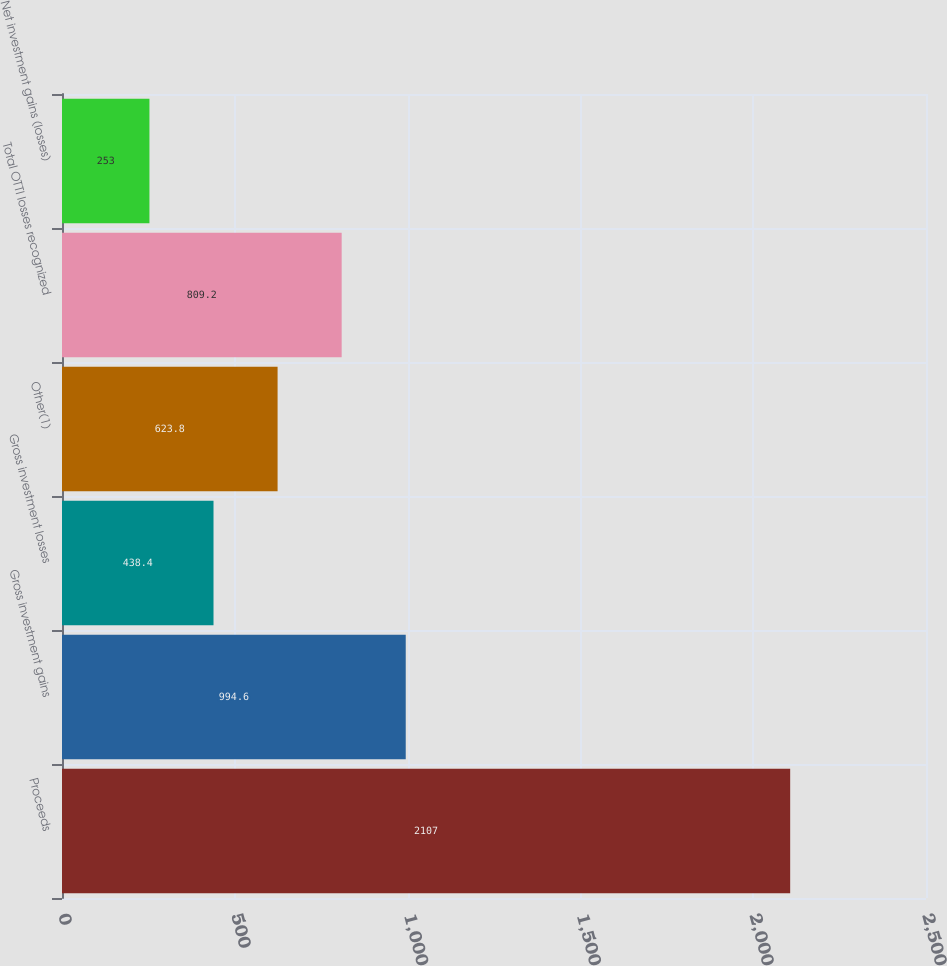<chart> <loc_0><loc_0><loc_500><loc_500><bar_chart><fcel>Proceeds<fcel>Gross investment gains<fcel>Gross investment losses<fcel>Other(1)<fcel>Total OTTI losses recognized<fcel>Net investment gains (losses)<nl><fcel>2107<fcel>994.6<fcel>438.4<fcel>623.8<fcel>809.2<fcel>253<nl></chart> 